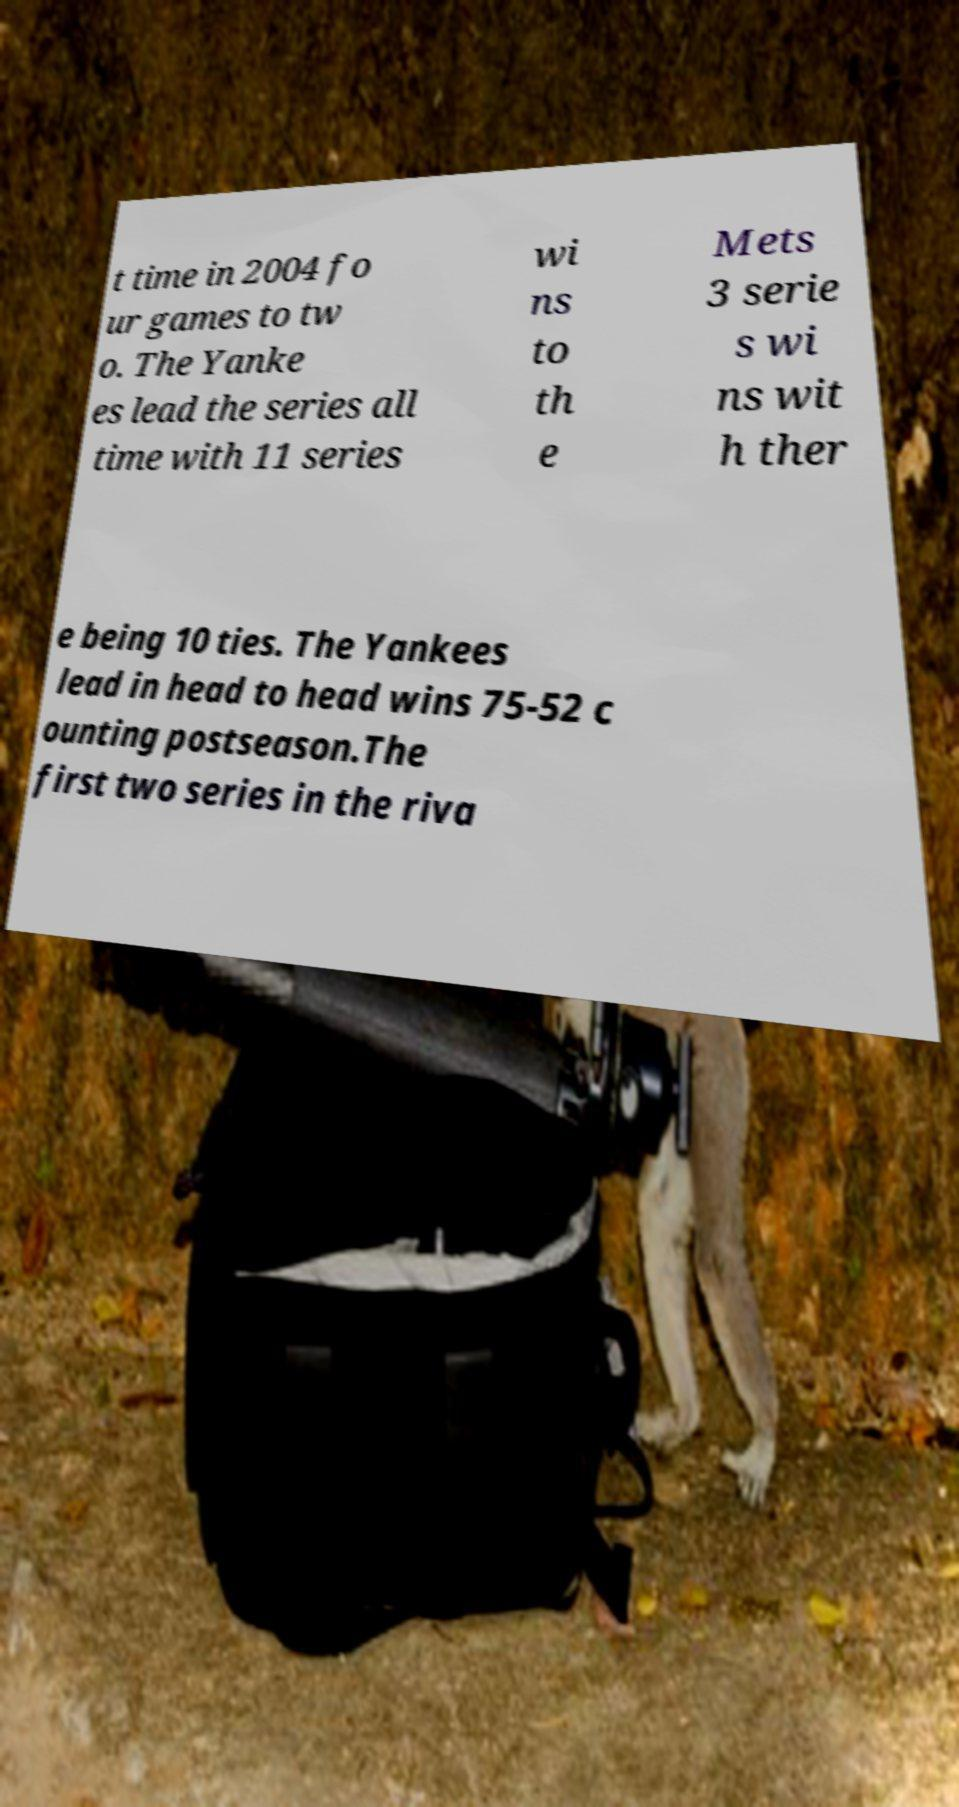Can you read and provide the text displayed in the image?This photo seems to have some interesting text. Can you extract and type it out for me? t time in 2004 fo ur games to tw o. The Yanke es lead the series all time with 11 series wi ns to th e Mets 3 serie s wi ns wit h ther e being 10 ties. The Yankees lead in head to head wins 75-52 c ounting postseason.The first two series in the riva 